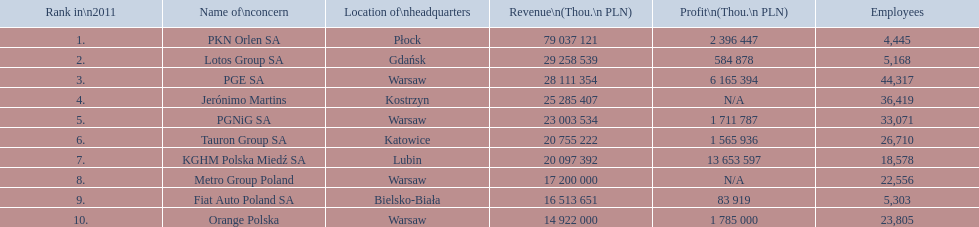What is the number of employees that work for pkn orlen sa in poland? 4,445. What number of employees work for lotos group sa? 5,168. How many people work for pgnig sa? 33,071. 